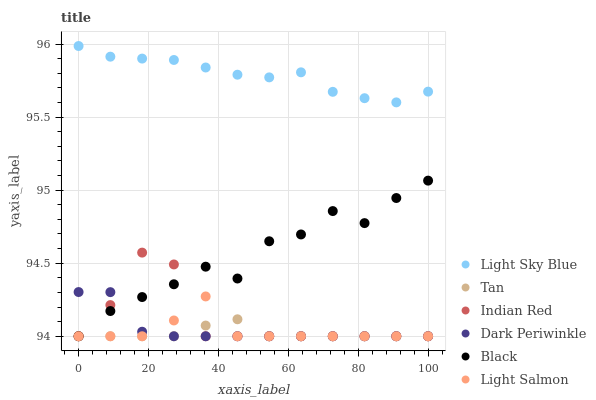Does Tan have the minimum area under the curve?
Answer yes or no. Yes. Does Light Sky Blue have the maximum area under the curve?
Answer yes or no. Yes. Does Black have the minimum area under the curve?
Answer yes or no. No. Does Black have the maximum area under the curve?
Answer yes or no. No. Is Tan the smoothest?
Answer yes or no. Yes. Is Black the roughest?
Answer yes or no. Yes. Is Light Sky Blue the smoothest?
Answer yes or no. No. Is Light Sky Blue the roughest?
Answer yes or no. No. Does Light Salmon have the lowest value?
Answer yes or no. Yes. Does Light Sky Blue have the lowest value?
Answer yes or no. No. Does Light Sky Blue have the highest value?
Answer yes or no. Yes. Does Black have the highest value?
Answer yes or no. No. Is Light Salmon less than Light Sky Blue?
Answer yes or no. Yes. Is Light Sky Blue greater than Tan?
Answer yes or no. Yes. Does Dark Periwinkle intersect Indian Red?
Answer yes or no. Yes. Is Dark Periwinkle less than Indian Red?
Answer yes or no. No. Is Dark Periwinkle greater than Indian Red?
Answer yes or no. No. Does Light Salmon intersect Light Sky Blue?
Answer yes or no. No. 